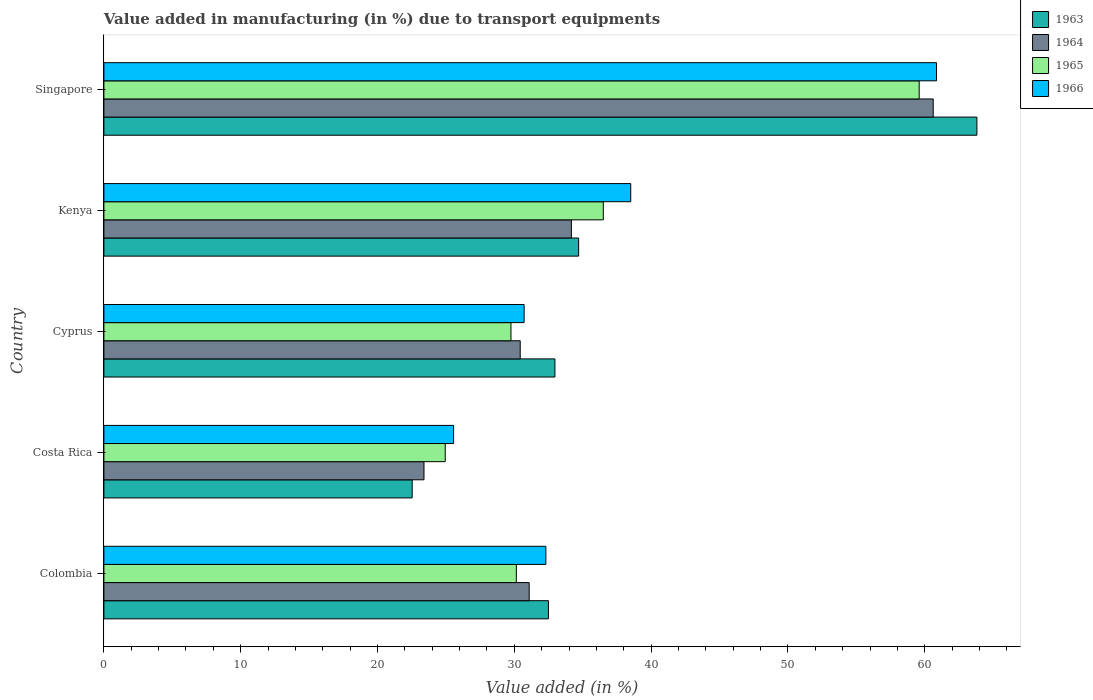How many different coloured bars are there?
Give a very brief answer. 4. How many bars are there on the 2nd tick from the top?
Offer a terse response. 4. How many bars are there on the 1st tick from the bottom?
Your response must be concise. 4. What is the label of the 1st group of bars from the top?
Provide a short and direct response. Singapore. What is the percentage of value added in manufacturing due to transport equipments in 1965 in Cyprus?
Your response must be concise. 29.75. Across all countries, what is the maximum percentage of value added in manufacturing due to transport equipments in 1964?
Give a very brief answer. 60.62. Across all countries, what is the minimum percentage of value added in manufacturing due to transport equipments in 1966?
Ensure brevity in your answer.  25.56. In which country was the percentage of value added in manufacturing due to transport equipments in 1965 maximum?
Offer a very short reply. Singapore. What is the total percentage of value added in manufacturing due to transport equipments in 1965 in the graph?
Ensure brevity in your answer.  180.94. What is the difference between the percentage of value added in manufacturing due to transport equipments in 1964 in Colombia and that in Costa Rica?
Give a very brief answer. 7.69. What is the difference between the percentage of value added in manufacturing due to transport equipments in 1963 in Colombia and the percentage of value added in manufacturing due to transport equipments in 1964 in Kenya?
Your answer should be compact. -1.68. What is the average percentage of value added in manufacturing due to transport equipments in 1966 per country?
Provide a succinct answer. 37.59. What is the difference between the percentage of value added in manufacturing due to transport equipments in 1963 and percentage of value added in manufacturing due to transport equipments in 1965 in Costa Rica?
Offer a terse response. -2.42. What is the ratio of the percentage of value added in manufacturing due to transport equipments in 1963 in Colombia to that in Cyprus?
Give a very brief answer. 0.99. What is the difference between the highest and the second highest percentage of value added in manufacturing due to transport equipments in 1964?
Your answer should be very brief. 26.45. What is the difference between the highest and the lowest percentage of value added in manufacturing due to transport equipments in 1964?
Provide a succinct answer. 37.22. What does the 3rd bar from the top in Singapore represents?
Provide a short and direct response. 1964. How many bars are there?
Your response must be concise. 20. Does the graph contain grids?
Ensure brevity in your answer.  No. Where does the legend appear in the graph?
Make the answer very short. Top right. How are the legend labels stacked?
Keep it short and to the point. Vertical. What is the title of the graph?
Provide a short and direct response. Value added in manufacturing (in %) due to transport equipments. What is the label or title of the X-axis?
Give a very brief answer. Value added (in %). What is the label or title of the Y-axis?
Your response must be concise. Country. What is the Value added (in %) of 1963 in Colombia?
Provide a short and direct response. 32.49. What is the Value added (in %) of 1964 in Colombia?
Your response must be concise. 31.09. What is the Value added (in %) of 1965 in Colombia?
Your answer should be compact. 30.15. What is the Value added (in %) in 1966 in Colombia?
Offer a very short reply. 32.3. What is the Value added (in %) in 1963 in Costa Rica?
Offer a very short reply. 22.53. What is the Value added (in %) of 1964 in Costa Rica?
Provide a succinct answer. 23.4. What is the Value added (in %) of 1965 in Costa Rica?
Provide a succinct answer. 24.95. What is the Value added (in %) of 1966 in Costa Rica?
Your answer should be compact. 25.56. What is the Value added (in %) of 1963 in Cyprus?
Provide a short and direct response. 32.97. What is the Value added (in %) of 1964 in Cyprus?
Your answer should be very brief. 30.43. What is the Value added (in %) of 1965 in Cyprus?
Your response must be concise. 29.75. What is the Value added (in %) in 1966 in Cyprus?
Make the answer very short. 30.72. What is the Value added (in %) in 1963 in Kenya?
Your response must be concise. 34.7. What is the Value added (in %) of 1964 in Kenya?
Keep it short and to the point. 34.17. What is the Value added (in %) in 1965 in Kenya?
Ensure brevity in your answer.  36.5. What is the Value added (in %) of 1966 in Kenya?
Offer a terse response. 38.51. What is the Value added (in %) in 1963 in Singapore?
Ensure brevity in your answer.  63.81. What is the Value added (in %) in 1964 in Singapore?
Ensure brevity in your answer.  60.62. What is the Value added (in %) of 1965 in Singapore?
Give a very brief answer. 59.59. What is the Value added (in %) in 1966 in Singapore?
Give a very brief answer. 60.86. Across all countries, what is the maximum Value added (in %) in 1963?
Ensure brevity in your answer.  63.81. Across all countries, what is the maximum Value added (in %) in 1964?
Your answer should be very brief. 60.62. Across all countries, what is the maximum Value added (in %) of 1965?
Keep it short and to the point. 59.59. Across all countries, what is the maximum Value added (in %) of 1966?
Your response must be concise. 60.86. Across all countries, what is the minimum Value added (in %) of 1963?
Your response must be concise. 22.53. Across all countries, what is the minimum Value added (in %) in 1964?
Ensure brevity in your answer.  23.4. Across all countries, what is the minimum Value added (in %) in 1965?
Your response must be concise. 24.95. Across all countries, what is the minimum Value added (in %) in 1966?
Offer a very short reply. 25.56. What is the total Value added (in %) in 1963 in the graph?
Ensure brevity in your answer.  186.5. What is the total Value added (in %) in 1964 in the graph?
Your answer should be very brief. 179.7. What is the total Value added (in %) of 1965 in the graph?
Your answer should be compact. 180.94. What is the total Value added (in %) in 1966 in the graph?
Offer a very short reply. 187.95. What is the difference between the Value added (in %) of 1963 in Colombia and that in Costa Rica?
Make the answer very short. 9.96. What is the difference between the Value added (in %) in 1964 in Colombia and that in Costa Rica?
Your answer should be compact. 7.69. What is the difference between the Value added (in %) of 1965 in Colombia and that in Costa Rica?
Provide a succinct answer. 5.2. What is the difference between the Value added (in %) of 1966 in Colombia and that in Costa Rica?
Your response must be concise. 6.74. What is the difference between the Value added (in %) in 1963 in Colombia and that in Cyprus?
Your answer should be compact. -0.47. What is the difference between the Value added (in %) of 1964 in Colombia and that in Cyprus?
Your answer should be compact. 0.66. What is the difference between the Value added (in %) in 1965 in Colombia and that in Cyprus?
Give a very brief answer. 0.39. What is the difference between the Value added (in %) in 1966 in Colombia and that in Cyprus?
Ensure brevity in your answer.  1.59. What is the difference between the Value added (in %) of 1963 in Colombia and that in Kenya?
Keep it short and to the point. -2.21. What is the difference between the Value added (in %) of 1964 in Colombia and that in Kenya?
Offer a terse response. -3.08. What is the difference between the Value added (in %) of 1965 in Colombia and that in Kenya?
Ensure brevity in your answer.  -6.36. What is the difference between the Value added (in %) of 1966 in Colombia and that in Kenya?
Your answer should be very brief. -6.2. What is the difference between the Value added (in %) in 1963 in Colombia and that in Singapore?
Your answer should be compact. -31.32. What is the difference between the Value added (in %) of 1964 in Colombia and that in Singapore?
Offer a terse response. -29.53. What is the difference between the Value added (in %) in 1965 in Colombia and that in Singapore?
Your answer should be very brief. -29.45. What is the difference between the Value added (in %) in 1966 in Colombia and that in Singapore?
Your response must be concise. -28.56. What is the difference between the Value added (in %) in 1963 in Costa Rica and that in Cyprus?
Provide a succinct answer. -10.43. What is the difference between the Value added (in %) of 1964 in Costa Rica and that in Cyprus?
Keep it short and to the point. -7.03. What is the difference between the Value added (in %) in 1965 in Costa Rica and that in Cyprus?
Ensure brevity in your answer.  -4.8. What is the difference between the Value added (in %) in 1966 in Costa Rica and that in Cyprus?
Provide a short and direct response. -5.16. What is the difference between the Value added (in %) of 1963 in Costa Rica and that in Kenya?
Keep it short and to the point. -12.17. What is the difference between the Value added (in %) of 1964 in Costa Rica and that in Kenya?
Offer a very short reply. -10.77. What is the difference between the Value added (in %) of 1965 in Costa Rica and that in Kenya?
Ensure brevity in your answer.  -11.55. What is the difference between the Value added (in %) in 1966 in Costa Rica and that in Kenya?
Your response must be concise. -12.95. What is the difference between the Value added (in %) in 1963 in Costa Rica and that in Singapore?
Provide a succinct answer. -41.28. What is the difference between the Value added (in %) in 1964 in Costa Rica and that in Singapore?
Ensure brevity in your answer.  -37.22. What is the difference between the Value added (in %) of 1965 in Costa Rica and that in Singapore?
Your answer should be very brief. -34.64. What is the difference between the Value added (in %) in 1966 in Costa Rica and that in Singapore?
Provide a short and direct response. -35.3. What is the difference between the Value added (in %) in 1963 in Cyprus and that in Kenya?
Your response must be concise. -1.73. What is the difference between the Value added (in %) in 1964 in Cyprus and that in Kenya?
Ensure brevity in your answer.  -3.74. What is the difference between the Value added (in %) of 1965 in Cyprus and that in Kenya?
Your response must be concise. -6.75. What is the difference between the Value added (in %) in 1966 in Cyprus and that in Kenya?
Provide a succinct answer. -7.79. What is the difference between the Value added (in %) of 1963 in Cyprus and that in Singapore?
Provide a short and direct response. -30.84. What is the difference between the Value added (in %) in 1964 in Cyprus and that in Singapore?
Make the answer very short. -30.19. What is the difference between the Value added (in %) of 1965 in Cyprus and that in Singapore?
Your answer should be very brief. -29.84. What is the difference between the Value added (in %) in 1966 in Cyprus and that in Singapore?
Offer a terse response. -30.14. What is the difference between the Value added (in %) of 1963 in Kenya and that in Singapore?
Your answer should be compact. -29.11. What is the difference between the Value added (in %) in 1964 in Kenya and that in Singapore?
Provide a succinct answer. -26.45. What is the difference between the Value added (in %) in 1965 in Kenya and that in Singapore?
Provide a succinct answer. -23.09. What is the difference between the Value added (in %) of 1966 in Kenya and that in Singapore?
Offer a terse response. -22.35. What is the difference between the Value added (in %) of 1963 in Colombia and the Value added (in %) of 1964 in Costa Rica?
Ensure brevity in your answer.  9.1. What is the difference between the Value added (in %) of 1963 in Colombia and the Value added (in %) of 1965 in Costa Rica?
Your response must be concise. 7.54. What is the difference between the Value added (in %) of 1963 in Colombia and the Value added (in %) of 1966 in Costa Rica?
Your answer should be very brief. 6.93. What is the difference between the Value added (in %) of 1964 in Colombia and the Value added (in %) of 1965 in Costa Rica?
Your answer should be compact. 6.14. What is the difference between the Value added (in %) in 1964 in Colombia and the Value added (in %) in 1966 in Costa Rica?
Provide a short and direct response. 5.53. What is the difference between the Value added (in %) in 1965 in Colombia and the Value added (in %) in 1966 in Costa Rica?
Ensure brevity in your answer.  4.59. What is the difference between the Value added (in %) of 1963 in Colombia and the Value added (in %) of 1964 in Cyprus?
Offer a very short reply. 2.06. What is the difference between the Value added (in %) in 1963 in Colombia and the Value added (in %) in 1965 in Cyprus?
Provide a succinct answer. 2.74. What is the difference between the Value added (in %) in 1963 in Colombia and the Value added (in %) in 1966 in Cyprus?
Keep it short and to the point. 1.78. What is the difference between the Value added (in %) in 1964 in Colombia and the Value added (in %) in 1965 in Cyprus?
Offer a very short reply. 1.33. What is the difference between the Value added (in %) of 1964 in Colombia and the Value added (in %) of 1966 in Cyprus?
Provide a short and direct response. 0.37. What is the difference between the Value added (in %) of 1965 in Colombia and the Value added (in %) of 1966 in Cyprus?
Your answer should be very brief. -0.57. What is the difference between the Value added (in %) of 1963 in Colombia and the Value added (in %) of 1964 in Kenya?
Your answer should be compact. -1.68. What is the difference between the Value added (in %) in 1963 in Colombia and the Value added (in %) in 1965 in Kenya?
Keep it short and to the point. -4.01. What is the difference between the Value added (in %) of 1963 in Colombia and the Value added (in %) of 1966 in Kenya?
Offer a terse response. -6.01. What is the difference between the Value added (in %) in 1964 in Colombia and the Value added (in %) in 1965 in Kenya?
Offer a very short reply. -5.42. What is the difference between the Value added (in %) in 1964 in Colombia and the Value added (in %) in 1966 in Kenya?
Your response must be concise. -7.42. What is the difference between the Value added (in %) in 1965 in Colombia and the Value added (in %) in 1966 in Kenya?
Provide a succinct answer. -8.36. What is the difference between the Value added (in %) of 1963 in Colombia and the Value added (in %) of 1964 in Singapore?
Your answer should be very brief. -28.12. What is the difference between the Value added (in %) in 1963 in Colombia and the Value added (in %) in 1965 in Singapore?
Offer a terse response. -27.1. What is the difference between the Value added (in %) of 1963 in Colombia and the Value added (in %) of 1966 in Singapore?
Offer a terse response. -28.37. What is the difference between the Value added (in %) in 1964 in Colombia and the Value added (in %) in 1965 in Singapore?
Make the answer very short. -28.51. What is the difference between the Value added (in %) in 1964 in Colombia and the Value added (in %) in 1966 in Singapore?
Provide a succinct answer. -29.77. What is the difference between the Value added (in %) in 1965 in Colombia and the Value added (in %) in 1966 in Singapore?
Provide a succinct answer. -30.71. What is the difference between the Value added (in %) in 1963 in Costa Rica and the Value added (in %) in 1964 in Cyprus?
Provide a short and direct response. -7.9. What is the difference between the Value added (in %) of 1963 in Costa Rica and the Value added (in %) of 1965 in Cyprus?
Give a very brief answer. -7.22. What is the difference between the Value added (in %) in 1963 in Costa Rica and the Value added (in %) in 1966 in Cyprus?
Make the answer very short. -8.18. What is the difference between the Value added (in %) of 1964 in Costa Rica and the Value added (in %) of 1965 in Cyprus?
Give a very brief answer. -6.36. What is the difference between the Value added (in %) of 1964 in Costa Rica and the Value added (in %) of 1966 in Cyprus?
Your answer should be very brief. -7.32. What is the difference between the Value added (in %) of 1965 in Costa Rica and the Value added (in %) of 1966 in Cyprus?
Provide a short and direct response. -5.77. What is the difference between the Value added (in %) of 1963 in Costa Rica and the Value added (in %) of 1964 in Kenya?
Keep it short and to the point. -11.64. What is the difference between the Value added (in %) in 1963 in Costa Rica and the Value added (in %) in 1965 in Kenya?
Your answer should be compact. -13.97. What is the difference between the Value added (in %) in 1963 in Costa Rica and the Value added (in %) in 1966 in Kenya?
Your response must be concise. -15.97. What is the difference between the Value added (in %) in 1964 in Costa Rica and the Value added (in %) in 1965 in Kenya?
Provide a short and direct response. -13.11. What is the difference between the Value added (in %) in 1964 in Costa Rica and the Value added (in %) in 1966 in Kenya?
Keep it short and to the point. -15.11. What is the difference between the Value added (in %) in 1965 in Costa Rica and the Value added (in %) in 1966 in Kenya?
Offer a terse response. -13.56. What is the difference between the Value added (in %) of 1963 in Costa Rica and the Value added (in %) of 1964 in Singapore?
Your answer should be very brief. -38.08. What is the difference between the Value added (in %) of 1963 in Costa Rica and the Value added (in %) of 1965 in Singapore?
Make the answer very short. -37.06. What is the difference between the Value added (in %) of 1963 in Costa Rica and the Value added (in %) of 1966 in Singapore?
Offer a terse response. -38.33. What is the difference between the Value added (in %) in 1964 in Costa Rica and the Value added (in %) in 1965 in Singapore?
Your response must be concise. -36.19. What is the difference between the Value added (in %) of 1964 in Costa Rica and the Value added (in %) of 1966 in Singapore?
Your response must be concise. -37.46. What is the difference between the Value added (in %) in 1965 in Costa Rica and the Value added (in %) in 1966 in Singapore?
Provide a short and direct response. -35.91. What is the difference between the Value added (in %) of 1963 in Cyprus and the Value added (in %) of 1964 in Kenya?
Your answer should be very brief. -1.2. What is the difference between the Value added (in %) in 1963 in Cyprus and the Value added (in %) in 1965 in Kenya?
Your answer should be compact. -3.54. What is the difference between the Value added (in %) in 1963 in Cyprus and the Value added (in %) in 1966 in Kenya?
Provide a succinct answer. -5.54. What is the difference between the Value added (in %) of 1964 in Cyprus and the Value added (in %) of 1965 in Kenya?
Offer a terse response. -6.07. What is the difference between the Value added (in %) in 1964 in Cyprus and the Value added (in %) in 1966 in Kenya?
Your answer should be compact. -8.08. What is the difference between the Value added (in %) in 1965 in Cyprus and the Value added (in %) in 1966 in Kenya?
Offer a very short reply. -8.75. What is the difference between the Value added (in %) of 1963 in Cyprus and the Value added (in %) of 1964 in Singapore?
Give a very brief answer. -27.65. What is the difference between the Value added (in %) of 1963 in Cyprus and the Value added (in %) of 1965 in Singapore?
Provide a succinct answer. -26.62. What is the difference between the Value added (in %) of 1963 in Cyprus and the Value added (in %) of 1966 in Singapore?
Keep it short and to the point. -27.89. What is the difference between the Value added (in %) of 1964 in Cyprus and the Value added (in %) of 1965 in Singapore?
Your answer should be very brief. -29.16. What is the difference between the Value added (in %) of 1964 in Cyprus and the Value added (in %) of 1966 in Singapore?
Keep it short and to the point. -30.43. What is the difference between the Value added (in %) of 1965 in Cyprus and the Value added (in %) of 1966 in Singapore?
Make the answer very short. -31.11. What is the difference between the Value added (in %) in 1963 in Kenya and the Value added (in %) in 1964 in Singapore?
Keep it short and to the point. -25.92. What is the difference between the Value added (in %) of 1963 in Kenya and the Value added (in %) of 1965 in Singapore?
Your answer should be compact. -24.89. What is the difference between the Value added (in %) in 1963 in Kenya and the Value added (in %) in 1966 in Singapore?
Your response must be concise. -26.16. What is the difference between the Value added (in %) in 1964 in Kenya and the Value added (in %) in 1965 in Singapore?
Your response must be concise. -25.42. What is the difference between the Value added (in %) in 1964 in Kenya and the Value added (in %) in 1966 in Singapore?
Your response must be concise. -26.69. What is the difference between the Value added (in %) in 1965 in Kenya and the Value added (in %) in 1966 in Singapore?
Ensure brevity in your answer.  -24.36. What is the average Value added (in %) of 1963 per country?
Your answer should be very brief. 37.3. What is the average Value added (in %) of 1964 per country?
Keep it short and to the point. 35.94. What is the average Value added (in %) of 1965 per country?
Ensure brevity in your answer.  36.19. What is the average Value added (in %) in 1966 per country?
Offer a very short reply. 37.59. What is the difference between the Value added (in %) of 1963 and Value added (in %) of 1964 in Colombia?
Provide a short and direct response. 1.41. What is the difference between the Value added (in %) in 1963 and Value added (in %) in 1965 in Colombia?
Provide a succinct answer. 2.35. What is the difference between the Value added (in %) in 1963 and Value added (in %) in 1966 in Colombia?
Ensure brevity in your answer.  0.19. What is the difference between the Value added (in %) in 1964 and Value added (in %) in 1965 in Colombia?
Provide a succinct answer. 0.94. What is the difference between the Value added (in %) of 1964 and Value added (in %) of 1966 in Colombia?
Make the answer very short. -1.22. What is the difference between the Value added (in %) in 1965 and Value added (in %) in 1966 in Colombia?
Offer a terse response. -2.16. What is the difference between the Value added (in %) of 1963 and Value added (in %) of 1964 in Costa Rica?
Give a very brief answer. -0.86. What is the difference between the Value added (in %) in 1963 and Value added (in %) in 1965 in Costa Rica?
Your answer should be very brief. -2.42. What is the difference between the Value added (in %) of 1963 and Value added (in %) of 1966 in Costa Rica?
Your answer should be very brief. -3.03. What is the difference between the Value added (in %) of 1964 and Value added (in %) of 1965 in Costa Rica?
Your response must be concise. -1.55. What is the difference between the Value added (in %) of 1964 and Value added (in %) of 1966 in Costa Rica?
Provide a short and direct response. -2.16. What is the difference between the Value added (in %) in 1965 and Value added (in %) in 1966 in Costa Rica?
Ensure brevity in your answer.  -0.61. What is the difference between the Value added (in %) of 1963 and Value added (in %) of 1964 in Cyprus?
Your response must be concise. 2.54. What is the difference between the Value added (in %) in 1963 and Value added (in %) in 1965 in Cyprus?
Give a very brief answer. 3.21. What is the difference between the Value added (in %) in 1963 and Value added (in %) in 1966 in Cyprus?
Provide a short and direct response. 2.25. What is the difference between the Value added (in %) in 1964 and Value added (in %) in 1965 in Cyprus?
Make the answer very short. 0.68. What is the difference between the Value added (in %) of 1964 and Value added (in %) of 1966 in Cyprus?
Ensure brevity in your answer.  -0.29. What is the difference between the Value added (in %) in 1965 and Value added (in %) in 1966 in Cyprus?
Your answer should be very brief. -0.96. What is the difference between the Value added (in %) of 1963 and Value added (in %) of 1964 in Kenya?
Make the answer very short. 0.53. What is the difference between the Value added (in %) of 1963 and Value added (in %) of 1965 in Kenya?
Your answer should be very brief. -1.8. What is the difference between the Value added (in %) of 1963 and Value added (in %) of 1966 in Kenya?
Make the answer very short. -3.81. What is the difference between the Value added (in %) of 1964 and Value added (in %) of 1965 in Kenya?
Your answer should be very brief. -2.33. What is the difference between the Value added (in %) of 1964 and Value added (in %) of 1966 in Kenya?
Your response must be concise. -4.34. What is the difference between the Value added (in %) in 1965 and Value added (in %) in 1966 in Kenya?
Make the answer very short. -2. What is the difference between the Value added (in %) of 1963 and Value added (in %) of 1964 in Singapore?
Your answer should be compact. 3.19. What is the difference between the Value added (in %) of 1963 and Value added (in %) of 1965 in Singapore?
Your answer should be very brief. 4.22. What is the difference between the Value added (in %) of 1963 and Value added (in %) of 1966 in Singapore?
Provide a short and direct response. 2.95. What is the difference between the Value added (in %) of 1964 and Value added (in %) of 1965 in Singapore?
Provide a short and direct response. 1.03. What is the difference between the Value added (in %) of 1964 and Value added (in %) of 1966 in Singapore?
Offer a terse response. -0.24. What is the difference between the Value added (in %) of 1965 and Value added (in %) of 1966 in Singapore?
Offer a very short reply. -1.27. What is the ratio of the Value added (in %) in 1963 in Colombia to that in Costa Rica?
Keep it short and to the point. 1.44. What is the ratio of the Value added (in %) of 1964 in Colombia to that in Costa Rica?
Make the answer very short. 1.33. What is the ratio of the Value added (in %) in 1965 in Colombia to that in Costa Rica?
Offer a terse response. 1.21. What is the ratio of the Value added (in %) in 1966 in Colombia to that in Costa Rica?
Provide a succinct answer. 1.26. What is the ratio of the Value added (in %) of 1963 in Colombia to that in Cyprus?
Give a very brief answer. 0.99. What is the ratio of the Value added (in %) of 1964 in Colombia to that in Cyprus?
Keep it short and to the point. 1.02. What is the ratio of the Value added (in %) in 1965 in Colombia to that in Cyprus?
Offer a terse response. 1.01. What is the ratio of the Value added (in %) of 1966 in Colombia to that in Cyprus?
Give a very brief answer. 1.05. What is the ratio of the Value added (in %) in 1963 in Colombia to that in Kenya?
Ensure brevity in your answer.  0.94. What is the ratio of the Value added (in %) in 1964 in Colombia to that in Kenya?
Provide a succinct answer. 0.91. What is the ratio of the Value added (in %) of 1965 in Colombia to that in Kenya?
Make the answer very short. 0.83. What is the ratio of the Value added (in %) of 1966 in Colombia to that in Kenya?
Your answer should be very brief. 0.84. What is the ratio of the Value added (in %) in 1963 in Colombia to that in Singapore?
Your response must be concise. 0.51. What is the ratio of the Value added (in %) of 1964 in Colombia to that in Singapore?
Make the answer very short. 0.51. What is the ratio of the Value added (in %) in 1965 in Colombia to that in Singapore?
Offer a very short reply. 0.51. What is the ratio of the Value added (in %) in 1966 in Colombia to that in Singapore?
Keep it short and to the point. 0.53. What is the ratio of the Value added (in %) in 1963 in Costa Rica to that in Cyprus?
Provide a short and direct response. 0.68. What is the ratio of the Value added (in %) in 1964 in Costa Rica to that in Cyprus?
Offer a terse response. 0.77. What is the ratio of the Value added (in %) of 1965 in Costa Rica to that in Cyprus?
Offer a very short reply. 0.84. What is the ratio of the Value added (in %) of 1966 in Costa Rica to that in Cyprus?
Give a very brief answer. 0.83. What is the ratio of the Value added (in %) of 1963 in Costa Rica to that in Kenya?
Ensure brevity in your answer.  0.65. What is the ratio of the Value added (in %) of 1964 in Costa Rica to that in Kenya?
Keep it short and to the point. 0.68. What is the ratio of the Value added (in %) in 1965 in Costa Rica to that in Kenya?
Ensure brevity in your answer.  0.68. What is the ratio of the Value added (in %) in 1966 in Costa Rica to that in Kenya?
Offer a terse response. 0.66. What is the ratio of the Value added (in %) of 1963 in Costa Rica to that in Singapore?
Your answer should be compact. 0.35. What is the ratio of the Value added (in %) of 1964 in Costa Rica to that in Singapore?
Your response must be concise. 0.39. What is the ratio of the Value added (in %) of 1965 in Costa Rica to that in Singapore?
Provide a succinct answer. 0.42. What is the ratio of the Value added (in %) of 1966 in Costa Rica to that in Singapore?
Your answer should be very brief. 0.42. What is the ratio of the Value added (in %) in 1963 in Cyprus to that in Kenya?
Provide a short and direct response. 0.95. What is the ratio of the Value added (in %) in 1964 in Cyprus to that in Kenya?
Make the answer very short. 0.89. What is the ratio of the Value added (in %) of 1965 in Cyprus to that in Kenya?
Your response must be concise. 0.82. What is the ratio of the Value added (in %) in 1966 in Cyprus to that in Kenya?
Your answer should be compact. 0.8. What is the ratio of the Value added (in %) of 1963 in Cyprus to that in Singapore?
Keep it short and to the point. 0.52. What is the ratio of the Value added (in %) of 1964 in Cyprus to that in Singapore?
Keep it short and to the point. 0.5. What is the ratio of the Value added (in %) of 1965 in Cyprus to that in Singapore?
Your response must be concise. 0.5. What is the ratio of the Value added (in %) in 1966 in Cyprus to that in Singapore?
Ensure brevity in your answer.  0.5. What is the ratio of the Value added (in %) in 1963 in Kenya to that in Singapore?
Make the answer very short. 0.54. What is the ratio of the Value added (in %) of 1964 in Kenya to that in Singapore?
Offer a very short reply. 0.56. What is the ratio of the Value added (in %) in 1965 in Kenya to that in Singapore?
Provide a succinct answer. 0.61. What is the ratio of the Value added (in %) of 1966 in Kenya to that in Singapore?
Provide a succinct answer. 0.63. What is the difference between the highest and the second highest Value added (in %) of 1963?
Make the answer very short. 29.11. What is the difference between the highest and the second highest Value added (in %) of 1964?
Your answer should be compact. 26.45. What is the difference between the highest and the second highest Value added (in %) of 1965?
Provide a short and direct response. 23.09. What is the difference between the highest and the second highest Value added (in %) of 1966?
Give a very brief answer. 22.35. What is the difference between the highest and the lowest Value added (in %) in 1963?
Provide a succinct answer. 41.28. What is the difference between the highest and the lowest Value added (in %) in 1964?
Ensure brevity in your answer.  37.22. What is the difference between the highest and the lowest Value added (in %) in 1965?
Provide a short and direct response. 34.64. What is the difference between the highest and the lowest Value added (in %) in 1966?
Ensure brevity in your answer.  35.3. 